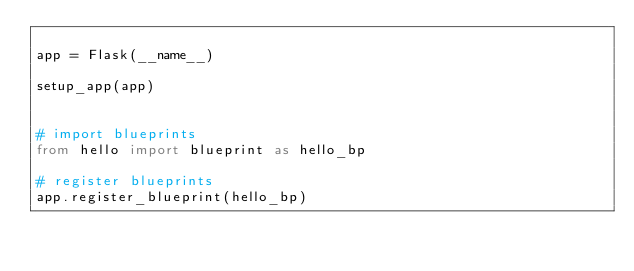<code> <loc_0><loc_0><loc_500><loc_500><_Python_>
app = Flask(__name__)

setup_app(app)


# import blueprints
from hello import blueprint as hello_bp

# register blueprints
app.register_blueprint(hello_bp)

</code> 